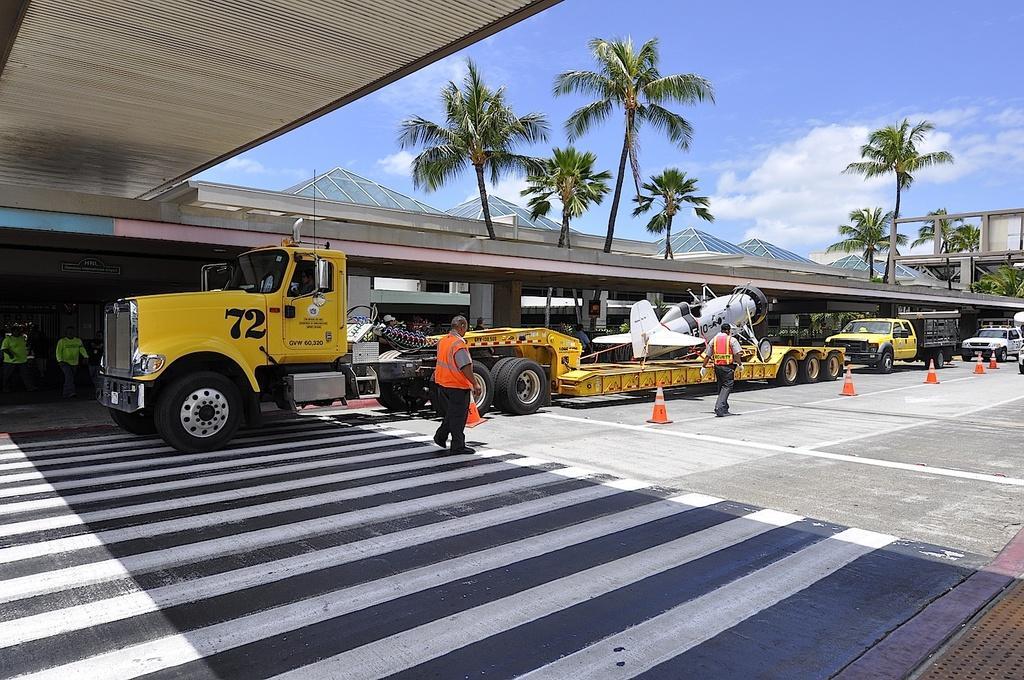How would you summarize this image in a sentence or two? In the picture we can see a truck and on the truck we can see an aircraft and behind it, we can see some vehicles on the road and in the background we can see the trees and the sky with clouds. 